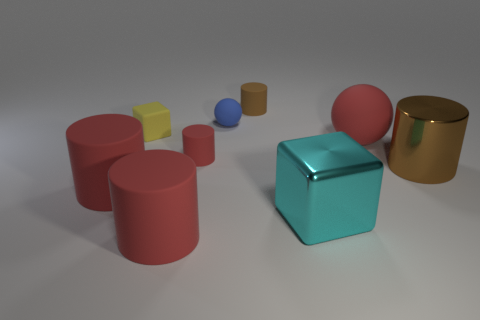What is the shape of the rubber thing that is right of the blue matte thing and in front of the yellow block?
Your response must be concise. Sphere. How many purple things are large cylinders or matte spheres?
Give a very brief answer. 0. Does the tiny cylinder that is behind the small red matte cylinder have the same color as the tiny ball?
Your response must be concise. No. What size is the sphere in front of the rubber sphere to the left of the big cyan cube?
Offer a terse response. Large. There is a cube that is the same size as the red sphere; what is its material?
Keep it short and to the point. Metal. How many other things are there of the same size as the red sphere?
Your response must be concise. 4. What number of balls are tiny red matte things or tiny blue things?
Your answer should be compact. 1. Is there any other thing that is the same material as the tiny ball?
Your answer should be compact. Yes. There is a brown thing that is on the right side of the cylinder that is behind the big red thing to the right of the tiny brown matte cylinder; what is its material?
Offer a terse response. Metal. There is a thing that is the same color as the large metal cylinder; what is its material?
Make the answer very short. Rubber. 